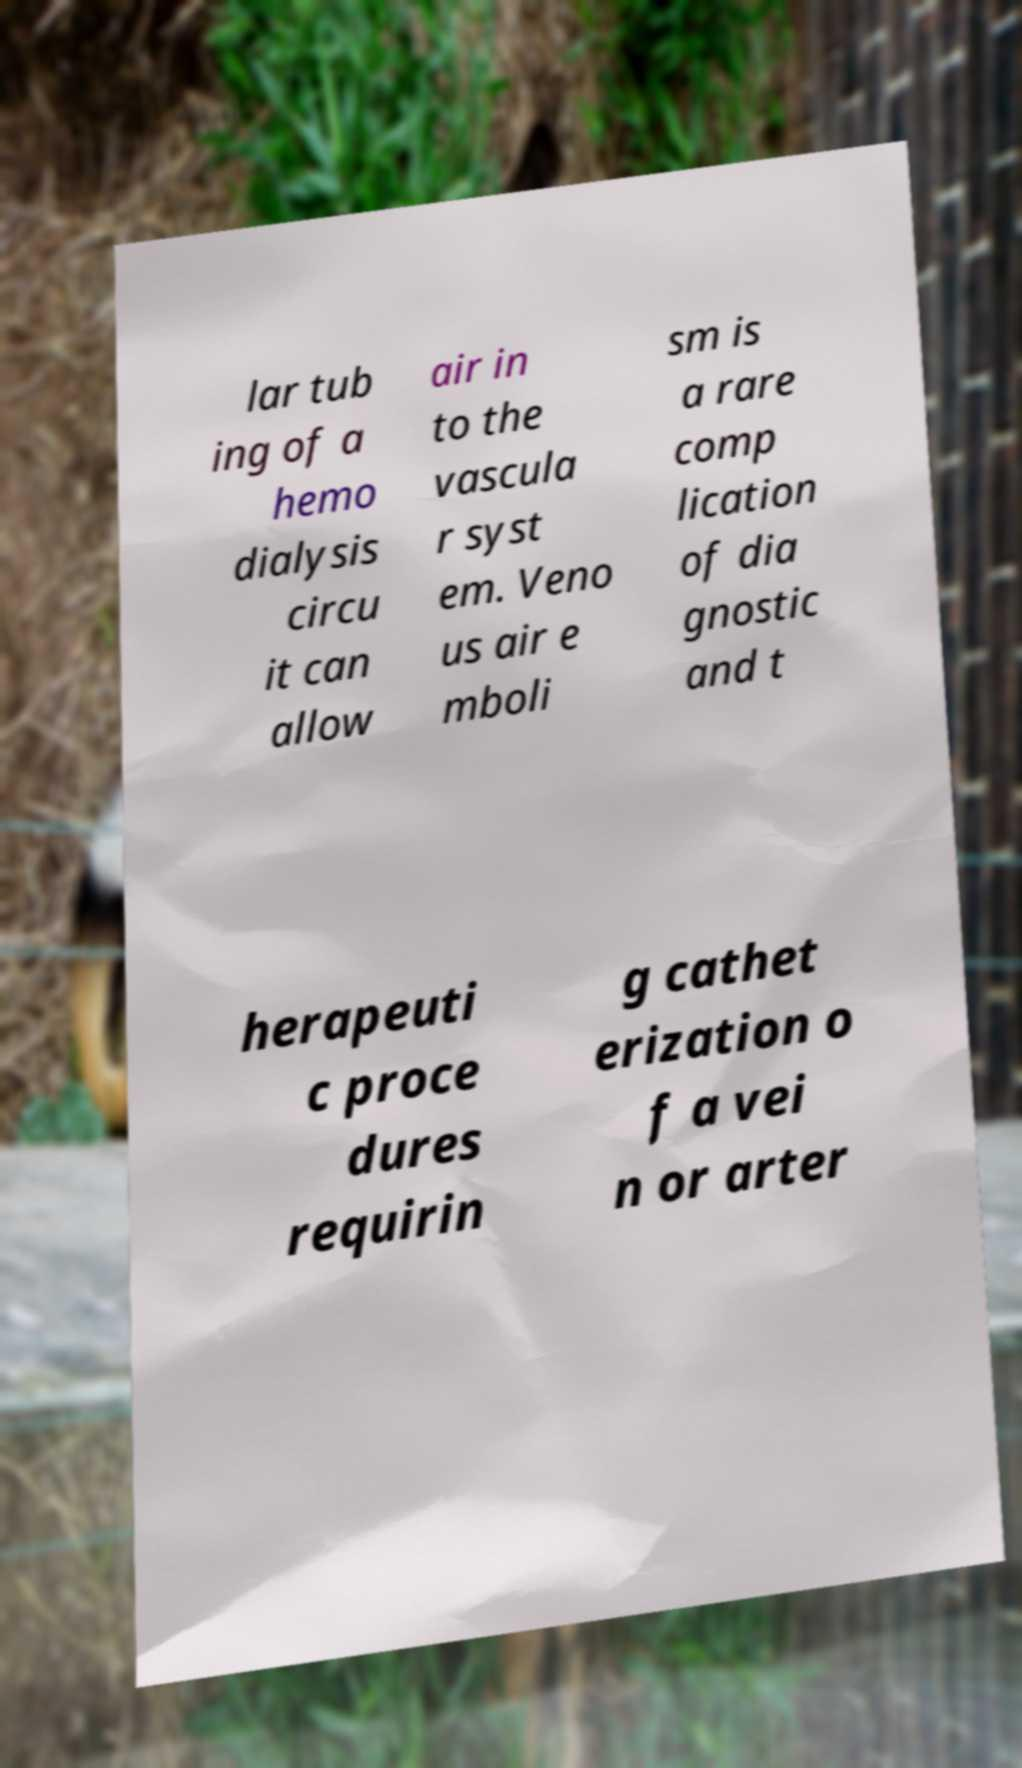What messages or text are displayed in this image? I need them in a readable, typed format. lar tub ing of a hemo dialysis circu it can allow air in to the vascula r syst em. Veno us air e mboli sm is a rare comp lication of dia gnostic and t herapeuti c proce dures requirin g cathet erization o f a vei n or arter 